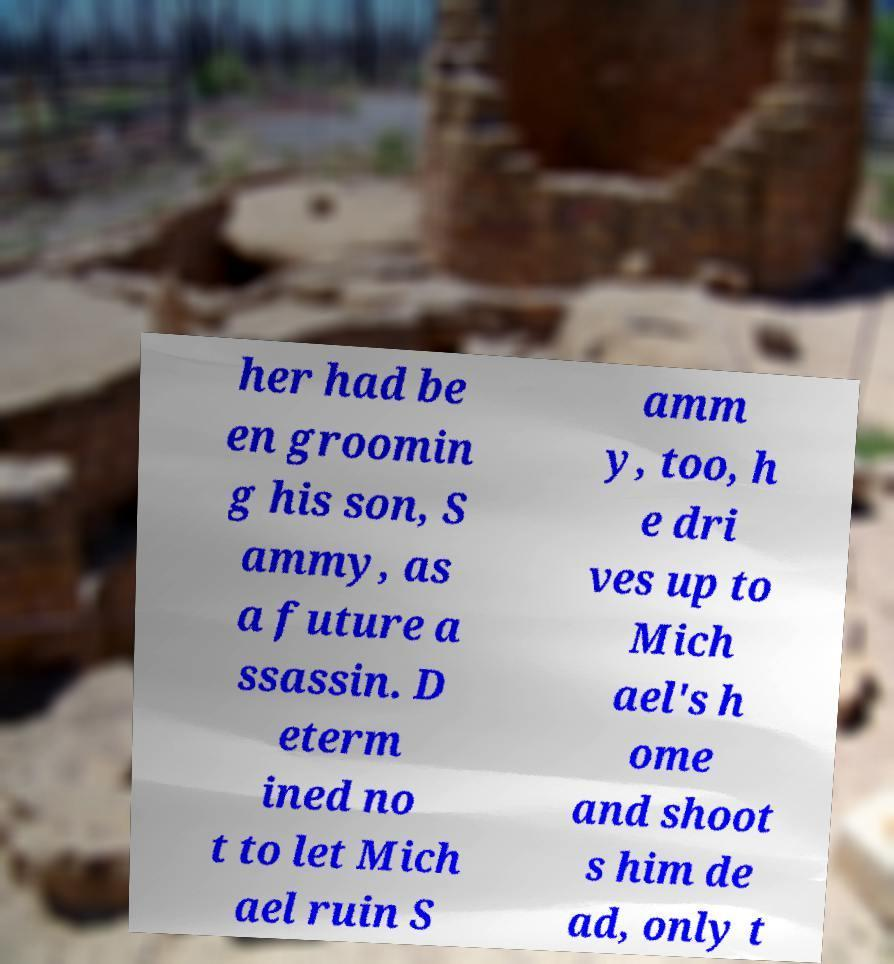Could you extract and type out the text from this image? her had be en groomin g his son, S ammy, as a future a ssassin. D eterm ined no t to let Mich ael ruin S amm y, too, h e dri ves up to Mich ael's h ome and shoot s him de ad, only t 